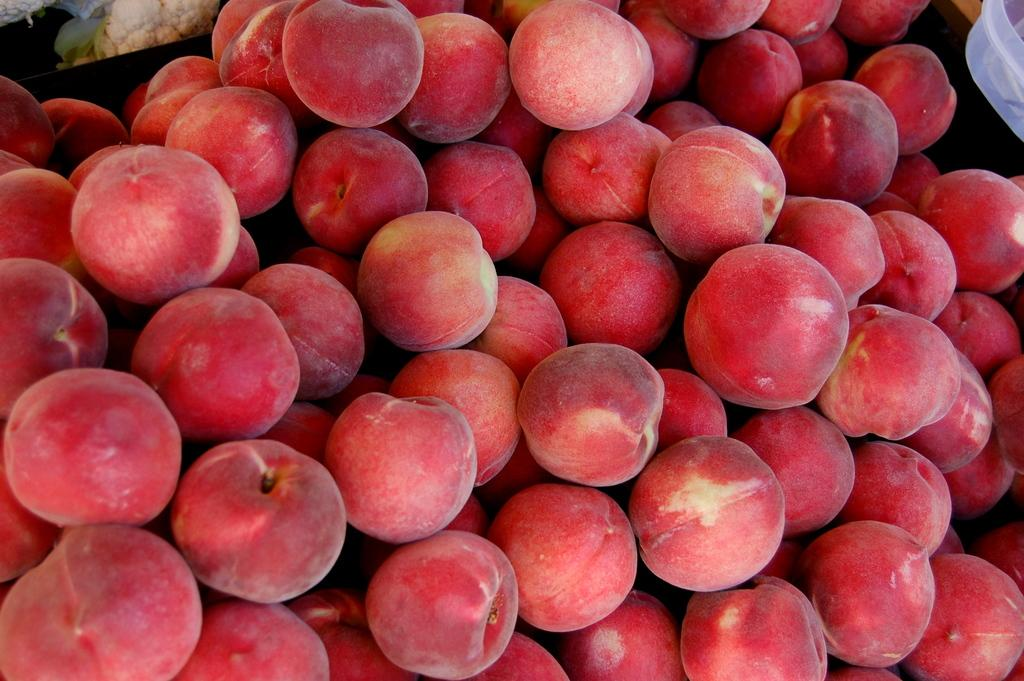What type of food items can be seen in the picture? There are fruits in the picture. Where is the plastic box located in the picture? The plastic box is in the top right corner of the picture. What vegetable can be seen in the top left corner of the picture? There appears to be a cauliflower in the top left corner of the picture. How many eyes does the cauliflower have in the picture? The cauliflower does not have eyes; it is a vegetable and does not have any facial features. 